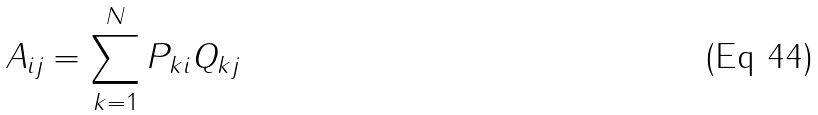Convert formula to latex. <formula><loc_0><loc_0><loc_500><loc_500>A _ { i j } = \sum _ { k = 1 } ^ { N } P _ { k i } Q _ { k j }</formula> 